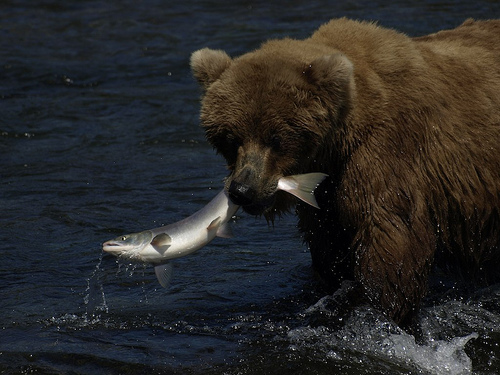What species of bear is depicted in the image? The image shows a brown bear, identifiable by its prominent shoulder hump, long snout, and shaggy brown fur. 